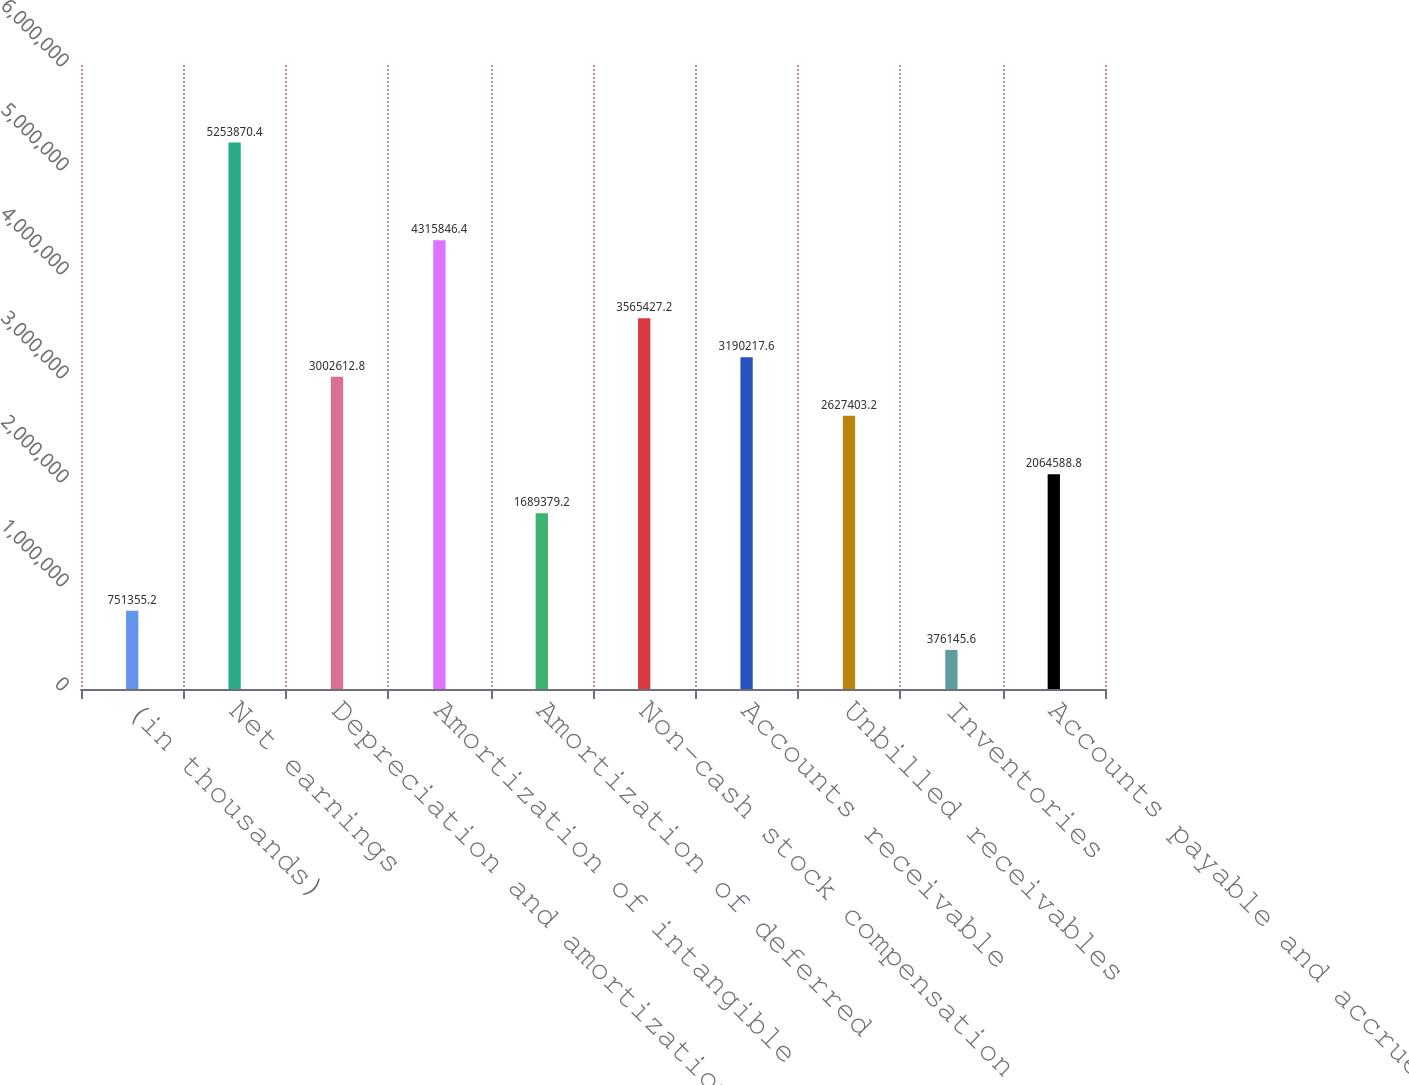<chart> <loc_0><loc_0><loc_500><loc_500><bar_chart><fcel>(in thousands)<fcel>Net earnings<fcel>Depreciation and amortization<fcel>Amortization of intangible<fcel>Amortization of deferred<fcel>Non-cash stock compensation<fcel>Accounts receivable<fcel>Unbilled receivables<fcel>Inventories<fcel>Accounts payable and accrued<nl><fcel>751355<fcel>5.25387e+06<fcel>3.00261e+06<fcel>4.31585e+06<fcel>1.68938e+06<fcel>3.56543e+06<fcel>3.19022e+06<fcel>2.6274e+06<fcel>376146<fcel>2.06459e+06<nl></chart> 